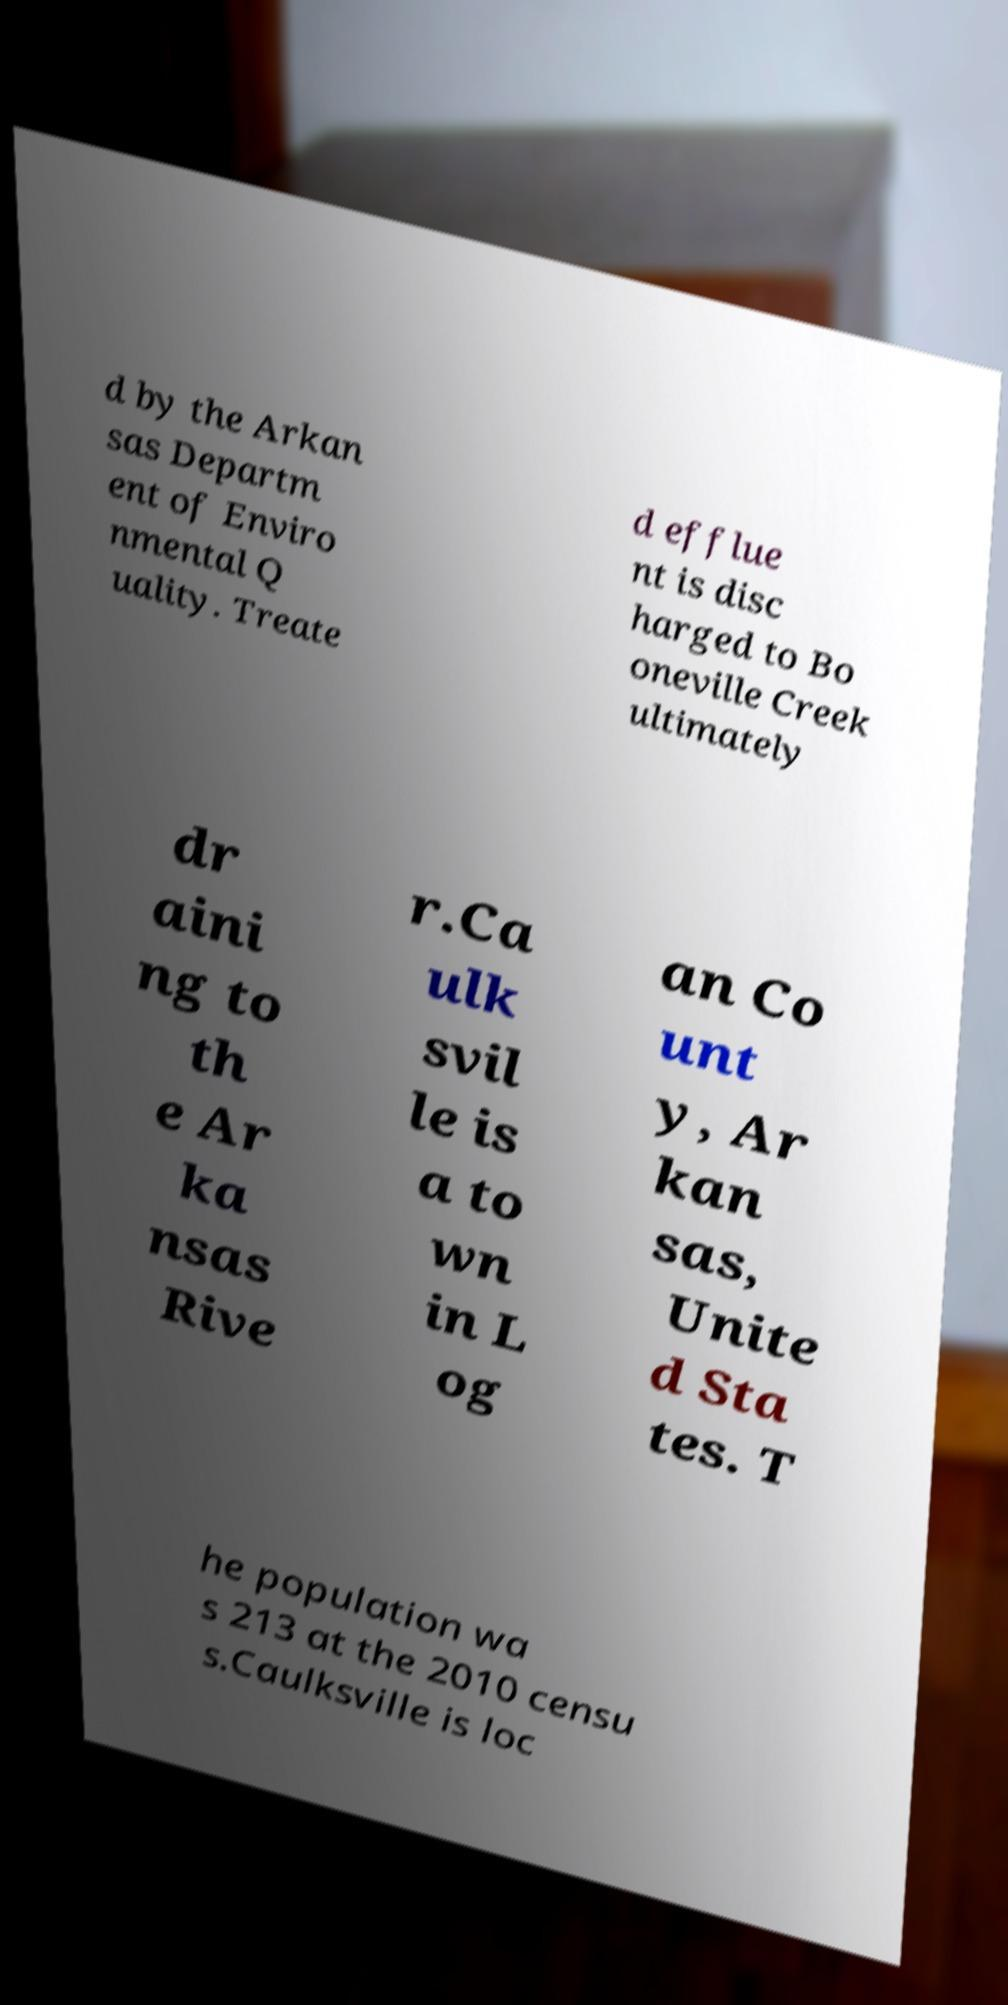Please identify and transcribe the text found in this image. d by the Arkan sas Departm ent of Enviro nmental Q uality. Treate d efflue nt is disc harged to Bo oneville Creek ultimately dr aini ng to th e Ar ka nsas Rive r.Ca ulk svil le is a to wn in L og an Co unt y, Ar kan sas, Unite d Sta tes. T he population wa s 213 at the 2010 censu s.Caulksville is loc 